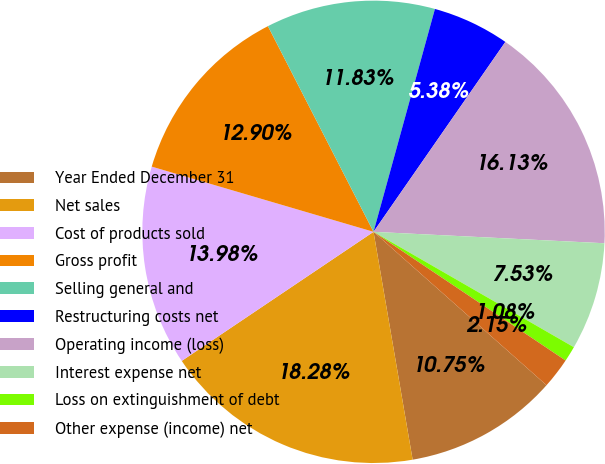Convert chart to OTSL. <chart><loc_0><loc_0><loc_500><loc_500><pie_chart><fcel>Year Ended December 31<fcel>Net sales<fcel>Cost of products sold<fcel>Gross profit<fcel>Selling general and<fcel>Restructuring costs net<fcel>Operating income (loss)<fcel>Interest expense net<fcel>Loss on extinguishment of debt<fcel>Other expense (income) net<nl><fcel>10.75%<fcel>18.28%<fcel>13.98%<fcel>12.9%<fcel>11.83%<fcel>5.38%<fcel>16.13%<fcel>7.53%<fcel>1.08%<fcel>2.15%<nl></chart> 